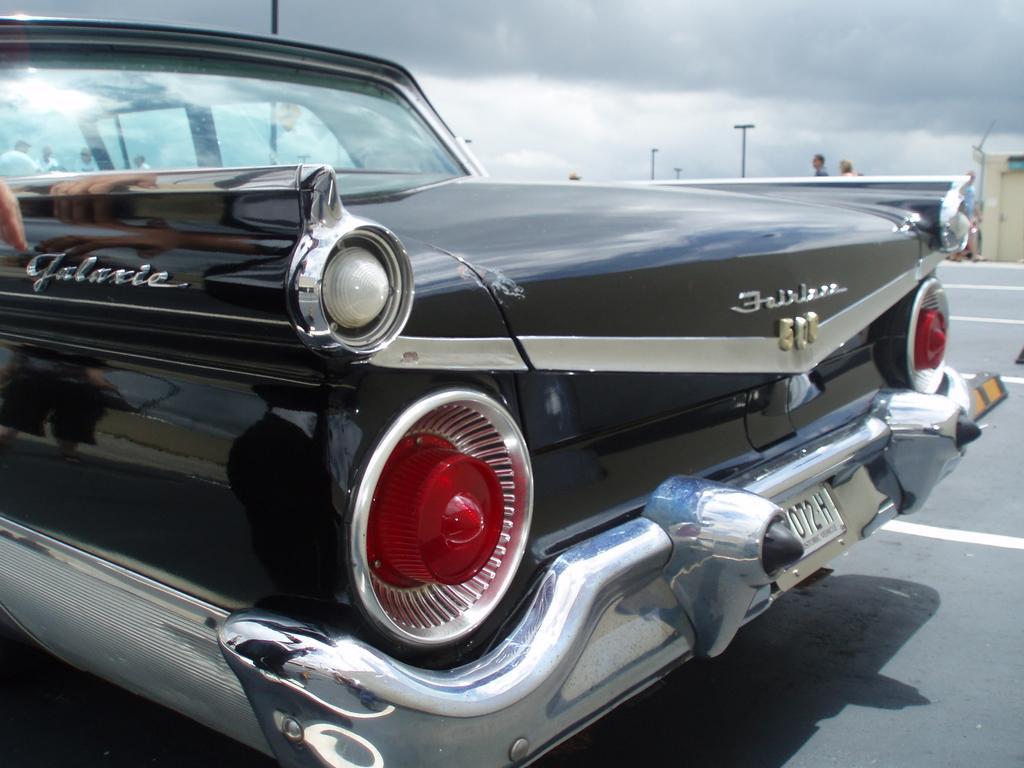Describe this image in one or two sentences. In this image there is a car on the road. Behind the car there are a few people. There are poles. In the background of the image there are clouds in the sky. 